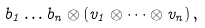Convert formula to latex. <formula><loc_0><loc_0><loc_500><loc_500>b _ { 1 } \dots b _ { n } \otimes ( v _ { 1 } \otimes \dots \otimes v _ { n } ) \, ,</formula> 